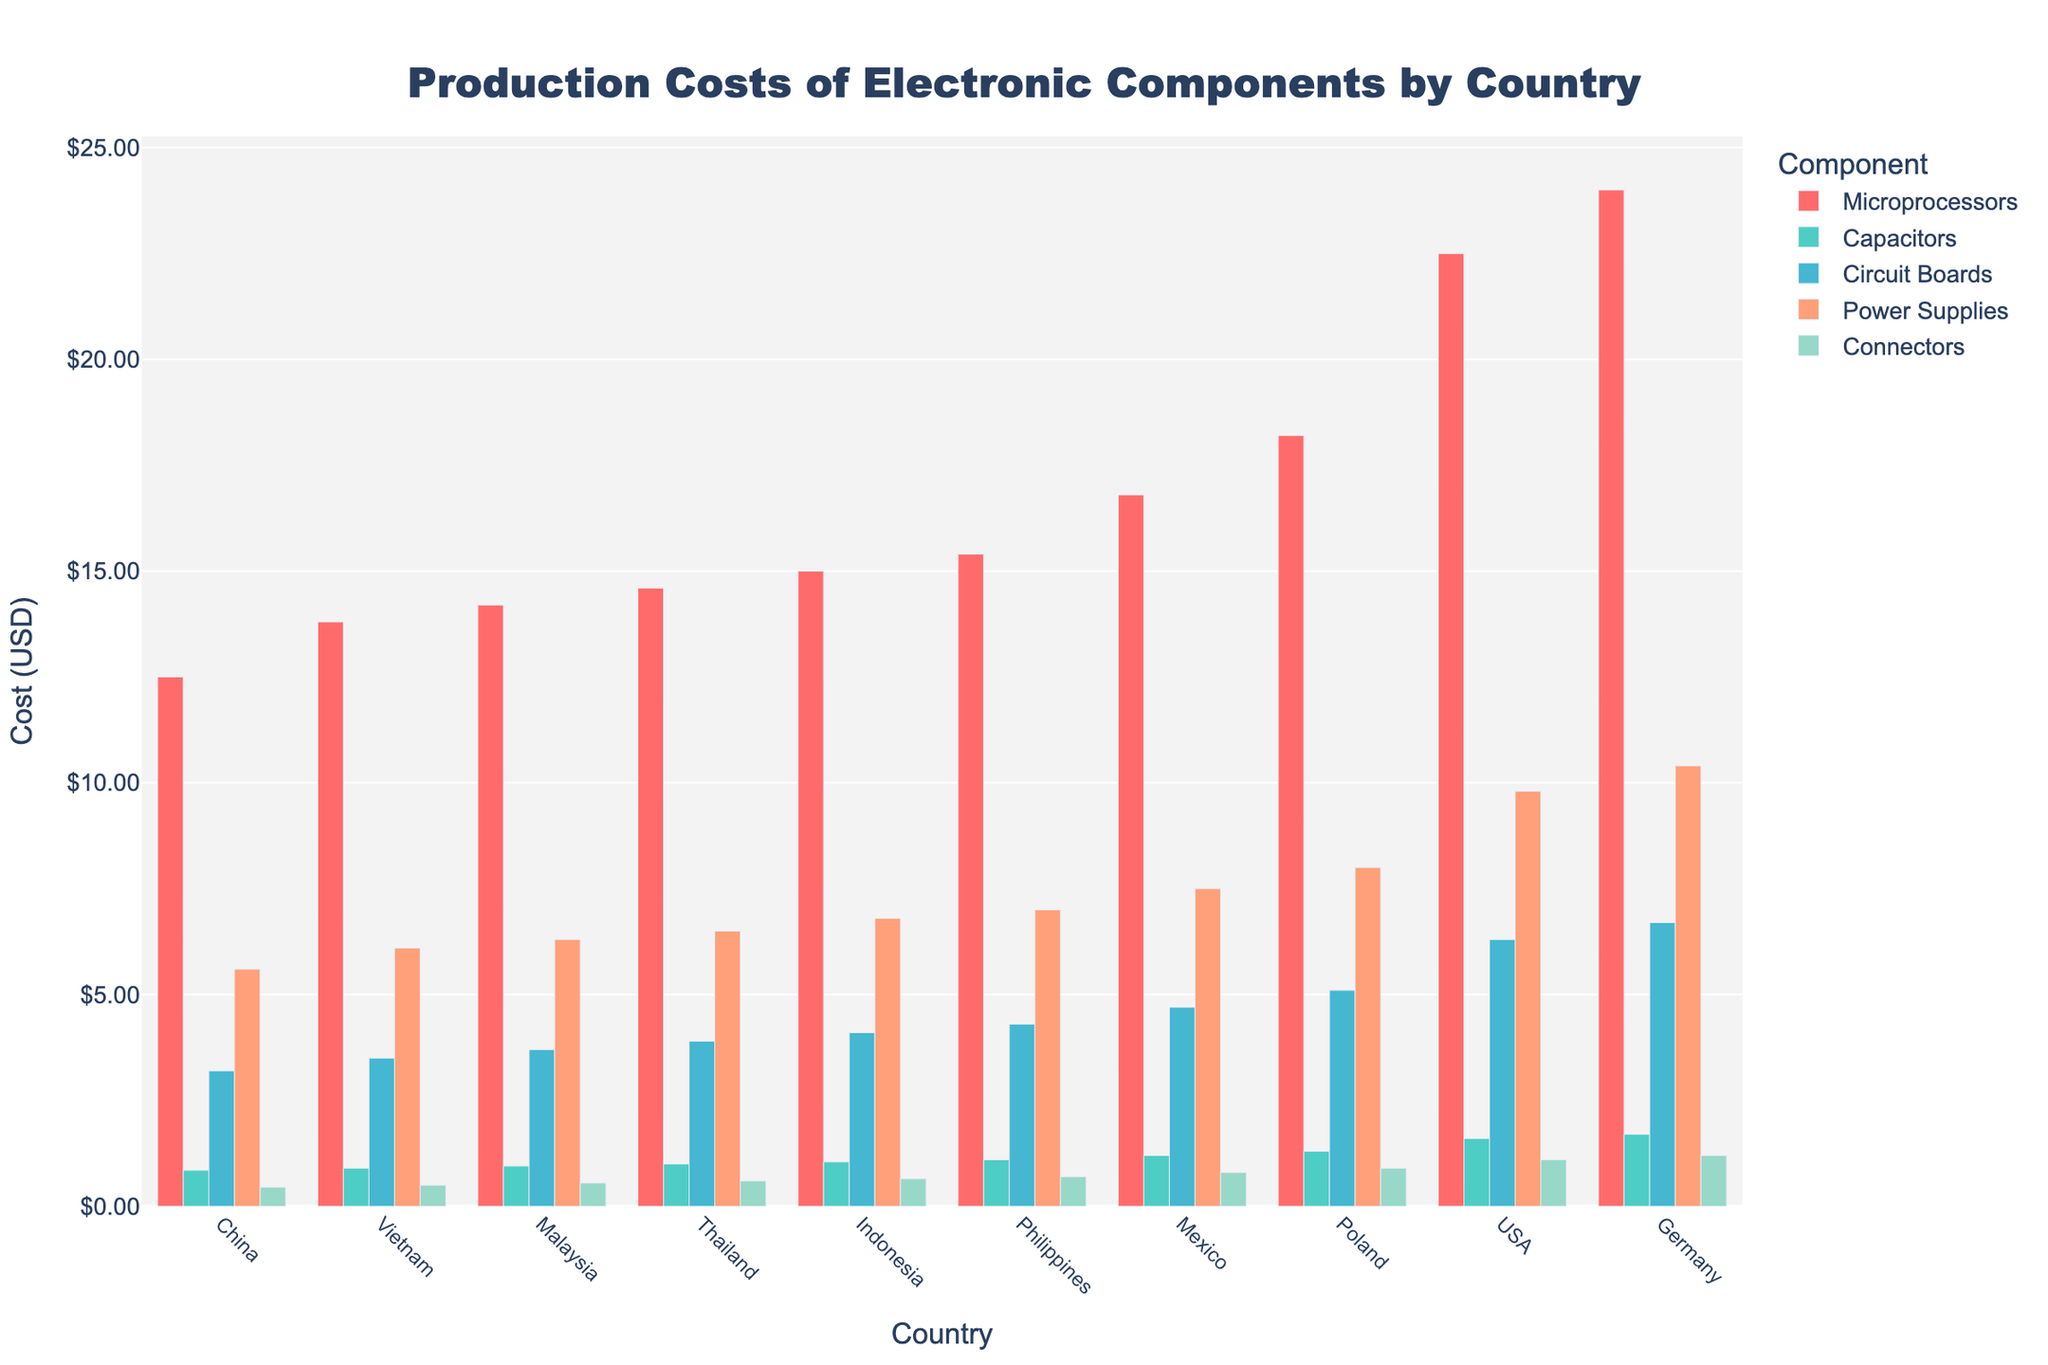Which country has the lowest production cost for microprocessors? By visually inspecting the bars representing microprocessors, the shortest bar corresponds to China. This indicates that China has the lowest production cost for microprocessors.
Answer: China Which component has the highest production cost in Germany? The tallest bar for Germany is observed for microprocessors. This indicates that microprocessors have the highest production cost in Germany.
Answer: Microprocessors What is the average production cost of power supplies in China and Vietnam? To find the average, add the production costs of power supplies in China and Vietnam and divide by 2. The costs are 5.60 for China and 6.10 for Vietnam. So, (5.60 + 6.10) / 2 = 5.85.
Answer: 5.85 How much more costly is it to produce connectors in Germany compared to Philippines? Determine the difference in costs between the two countries for connectors. Germany's cost is 1.20 and Philippines' is 0.70. So, 1.20 - 0.70 = 0.50.
Answer: 0.50 Which country has the smallest difference in production cost between capacitors and connectors? Calculate the difference for each country and find the smallest one. For China (0.85 - 0.45 = 0.40), Vietnam (0.90 - 0.50 = 0.40), Malaysia (0.95 - 0.55 = 0.40), Thailand (1.00 - 0.60 = 0.40), Indonesia (1.05 - 0.65 = 0.40), Philippines (1.10 - 0.70 = 0.40), Mexico (1.20 - 0.80 = 0.40), Poland (1.30 - 0.90 = 0.40), USA (1.60 - 1.10 = 0.50), Germany (1.70 - 1.20 = 0.50). The smallest difference of 0.40 is for China, Vietnam, Malaysia, Thailand, Indonesia, Philippines, Mexico, and Poland.
Answer: China, Vietnam, Malaysia, Thailand, Indonesia, Philippines, Mexico, Poland Which three countries have the highest production costs for circuit boards? Visually compare the heights of the bars for circuit boards across all countries. The tallest three bars are for Germany (6.70), USA (6.30), and Poland (5.10).
Answer: Germany, USA, Poland By how much do the production costs of capacitors differ between the country with the highest cost and the country with the lowest cost? Subtract the lowest cost from the highest cost for capacitors. The highest cost is in Germany (1.70) and the lowest is in China (0.85). Therefore, 1.70 - 0.85 = 0.85.
Answer: 0.85 What is the total production cost for all components combined in Mexico? Sum the production costs of all components in Mexico: 16.80 (Microprocessors) + 1.20 (Capacitors) + 4.70 (Circuit Boards) + 7.50 (Power Supplies) + 0.80 (Connectors). So, 16.80 + 1.20 + 4.70 + 7.50 + 0.80 = 31.00.
Answer: 31.00 